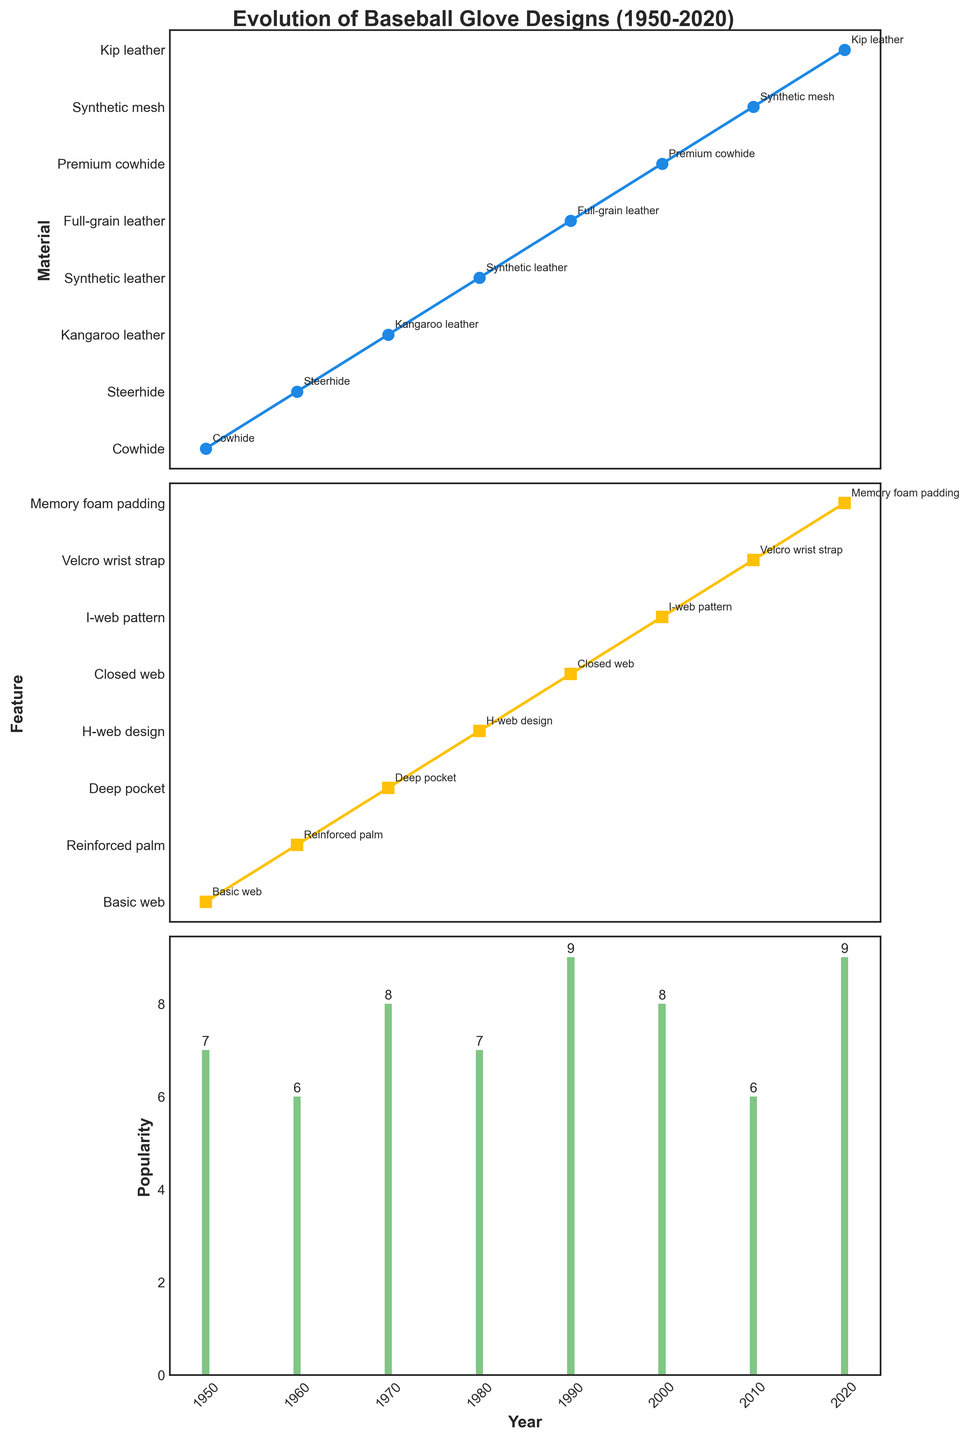What materials were used in baseball gloves during the 1950s and 1960s? The materials can be determined by looking at the individual points in the first subplot labeled 'Materials'. For the 1950s, the material listed is Cowhide, and for the 1960s, it is Steerhide.
Answer: Cowhide and Steerhide Which year had the highest popularity of baseball gloves? Refer to the third subplot labeled 'Popularity' and identify the tallest bar. The highest popularity value is 9 in the years 1990 and 2020, so either year can be considered.
Answer: 1990 or 2020 How many different glove features are shown from 1950 to 2020? Check the second subplot labeled 'Features' and count the unique annotations. The features listed are Basic web, Reinforced palm, Deep pocket, H-web design, Closed web, I-web pattern, Velcro wrist strap, and Memory foam padding, making it a total of 8 unique features.
Answer: 8 Is the popularity trend generally increasing, decreasing, or fluctuating over the years? By observing the third subplot on 'Popularity', one can see that the bar height varies but shows an increasing trend over time, especially toward the year 2020.
Answer: Increasing Which material was introduced first, Synthetic leather or Kip leather, and in which decades? The first subplot shows the materials used over various years. Synthetic leather appears in the 1980s while Kip leather appears in the 2020s. Hence, Synthetic leather was introduced earlier, in the 1980s.
Answer: Synthetic leather in the 1980s What type of web design was commonly used in the 1980s and 1990s? Check the annotations in the second subplot titled 'Feature'. For the 1980s, the feature is H-web design and for the 1990s, the feature is Closed web. Therefore, H-web design was used in the 1980s while Closed web was used in the 1990s.
Answer: H-web design and Closed web How does the popularity in the 1970s compare to that in the 2010s? Refer to the third subplot 'Popularity' and compare the heights of the bars for the years 1970 and 2010. The popularity in the 1970s is 8, whereas in the 2010s it is 6. Thus, the popularity in the 1970s is higher than in the 2010s.
Answer: Higher in the 1970s What is the trend in the features of gloves from 1990 to 2020? Look at the second subplot 'Features' and follow the data points (annotations) from 1990 to 2020. The features go from Closed web in 1990, I-web pattern in 2000, Velcro wrist strap in 2010, to Memory foam padding in 2020. These features suggest a trend towards more advanced and customizable features.
Answer: More advanced and customizable features 